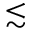Convert formula to latex. <formula><loc_0><loc_0><loc_500><loc_500>{ \lesssim }</formula> 